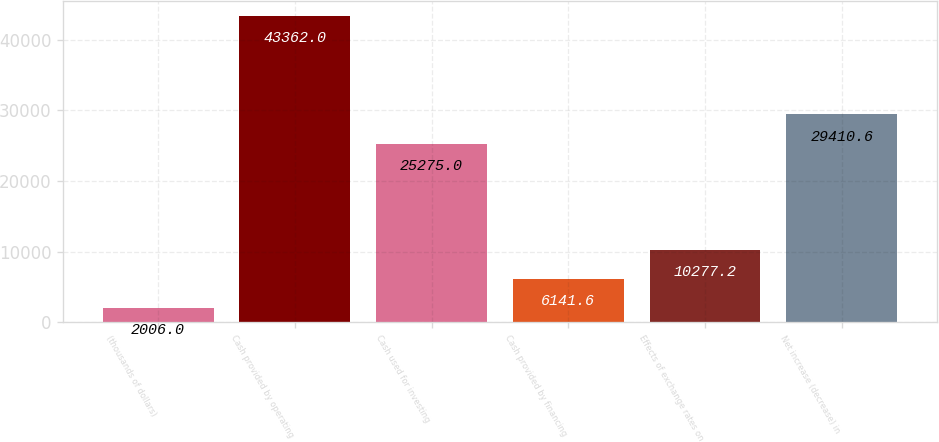Convert chart to OTSL. <chart><loc_0><loc_0><loc_500><loc_500><bar_chart><fcel>(thousands of dollars)<fcel>Cash provided by operating<fcel>Cash used for investing<fcel>Cash provided by financing<fcel>Effects of exchange rates on<fcel>Net increase (decrease) in<nl><fcel>2006<fcel>43362<fcel>25275<fcel>6141.6<fcel>10277.2<fcel>29410.6<nl></chart> 